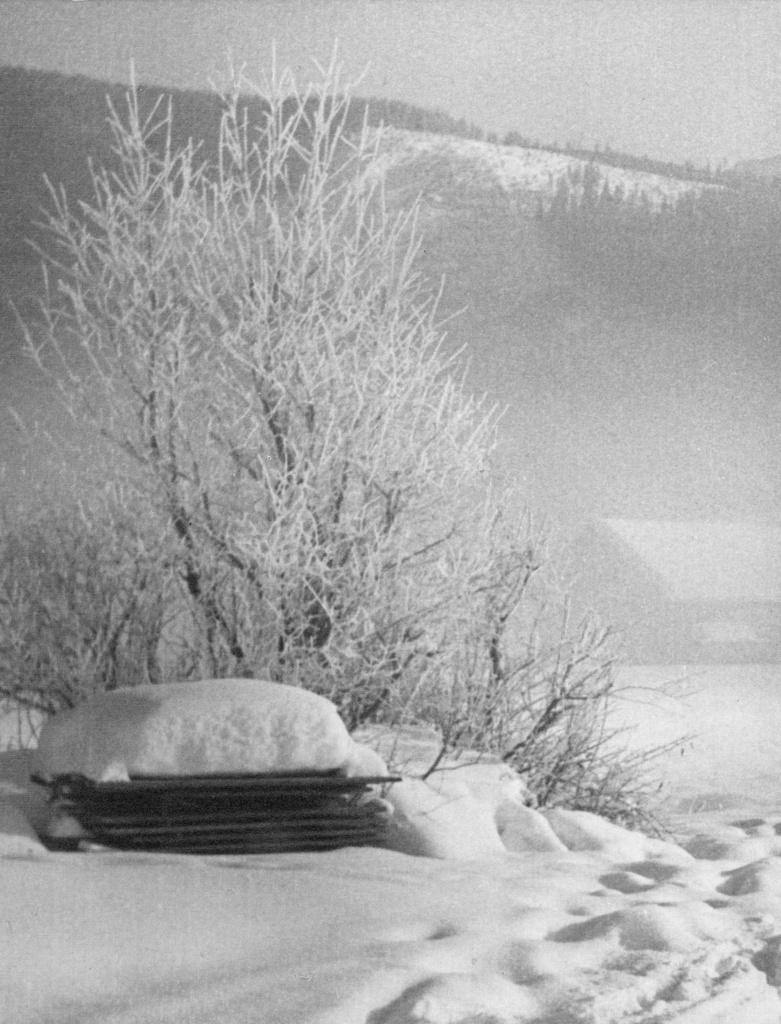What is the condition of the trees, house, and bench in the image? The trees, house, and bench are covered in snow in the image. What can be seen in the background of the image? There is a mountain and many trees in the background of the image. What is visible at the top of the image? The sky is visible at the top of the image. What is the weather like in the image? The presence of snow on the trees, house, and bench, as well as clouds in the sky, suggests a snowy or wintry scene. Can you see any wounded animals at the zoo in the image? There is no zoo present in the image, and therefore no wounded animals can be observed. How many quarters are visible on the bench in the image? There are no quarters visible on the bench in the image. 